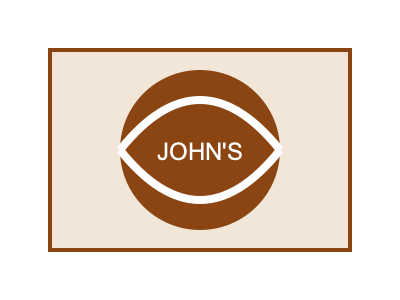Which design element in the storefront sign would best emphasize the bakery's warm and inviting atmosphere while maintaining visual balance? 1. Analyze the current design elements:
   - Rectangular background (warm, light brown color)
   - Circular center element (dark brown)
   - Text "JOHN'S" in white
   - Two curved white lines forming a bread-like shape

2. Consider the principles of visual balance:
   - The circular element provides a focal point
   - The curved lines add movement and softness

3. Evaluate color psychology:
   - Brown tones evoke warmth, comfort, and earthiness
   - White represents cleanliness and purity

4. Assess the impact of shapes:
   - The circular shape suggests unity and completeness
   - The curved lines mimic the shape of bread, relating to the bakery theme

5. Determine the element that best emphasizes warmth and inviting atmosphere:
   - The curved white lines resemble a stylized loaf of bread
   - They add movement and softness to the design
   - The curves create a sense of openness and invitation

6. Consider how this element maintains visual balance:
   - The curves complement the circular shape
   - They frame the text and logo, creating harmony
   - The white color balances the dark brown circle

Therefore, the curved white lines best emphasize the bakery's warm and inviting atmosphere while maintaining visual balance in the storefront sign design.
Answer: The curved white lines resembling a bread shape 